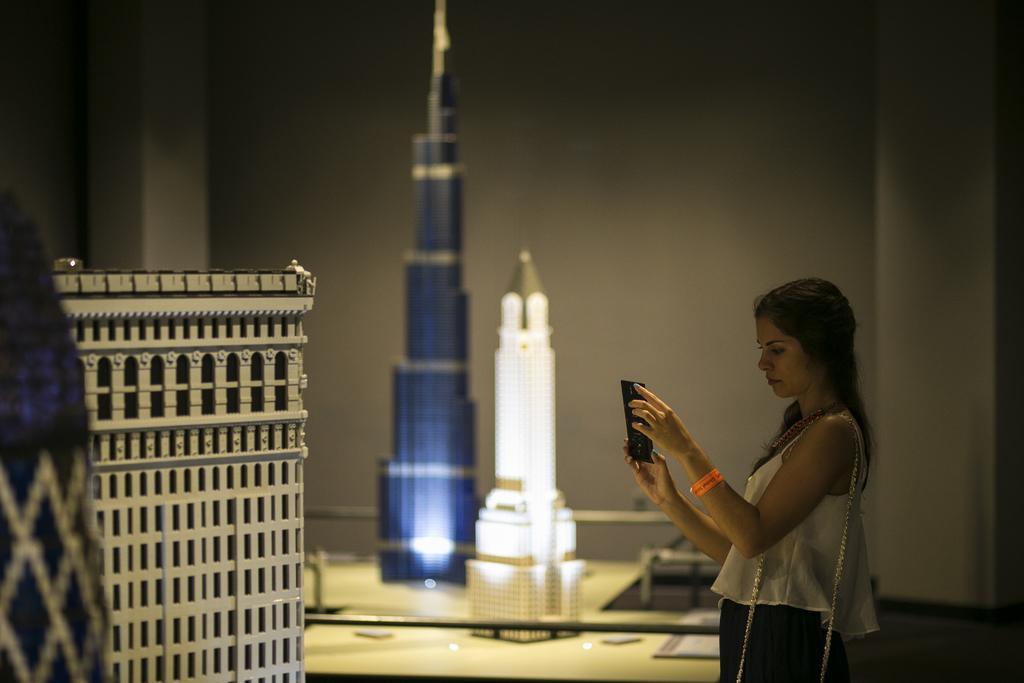Please provide a concise description of this image. In this image I can see the person wearing the white and black color dress and holding the mobile. In-front of the person I can see the miniature of the buildings. In the background I can see the wall. 